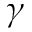Convert formula to latex. <formula><loc_0><loc_0><loc_500><loc_500>\gamma</formula> 